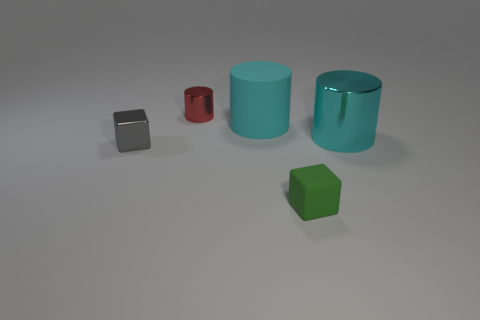Do the cube that is to the left of the red thing and the tiny green matte cube have the same size?
Your response must be concise. Yes. What is the material of the small cube that is to the right of the small red shiny cylinder?
Your answer should be very brief. Rubber. Is there any other thing that has the same shape as the red object?
Keep it short and to the point. Yes. What number of metal things are either big cyan things or small cubes?
Offer a terse response. 2. Are there fewer rubber things that are on the right side of the small green matte block than small gray metal cubes?
Your answer should be compact. Yes. The thing that is behind the matte object behind the block left of the matte cube is what shape?
Offer a terse response. Cylinder. Is the shiny cube the same color as the small rubber thing?
Offer a very short reply. No. Are there more cyan shiny objects than shiny cylinders?
Your response must be concise. No. How many other objects are there of the same material as the tiny gray block?
Your response must be concise. 2. How many things are either large cyan metal cylinders or tiny green objects in front of the big metallic cylinder?
Provide a short and direct response. 2. 